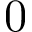Convert formula to latex. <formula><loc_0><loc_0><loc_500><loc_500>0</formula> 